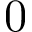Convert formula to latex. <formula><loc_0><loc_0><loc_500><loc_500>0</formula> 